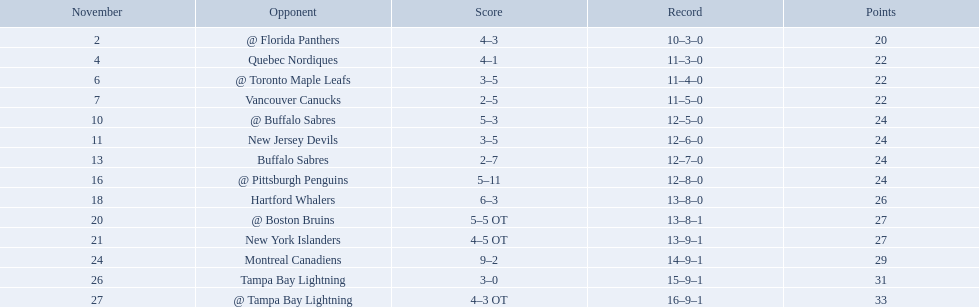What were the scores of the 1993-94 philadelphia flyers season? 4–3, 4–1, 3–5, 2–5, 5–3, 3–5, 2–7, 5–11, 6–3, 5–5 OT, 4–5 OT, 9–2, 3–0, 4–3 OT. Which of these teams had the score 4-5 ot? New York Islanders. 